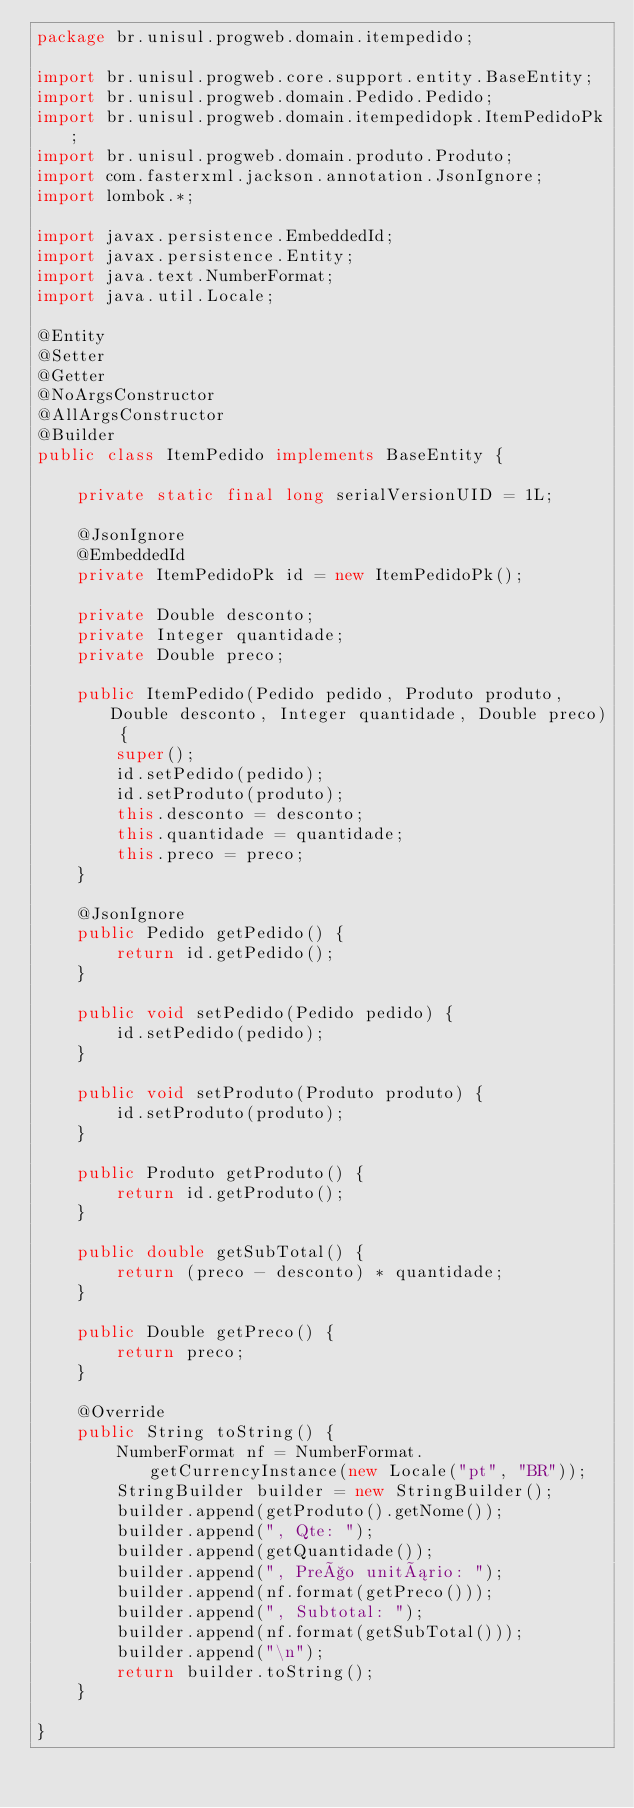Convert code to text. <code><loc_0><loc_0><loc_500><loc_500><_Java_>package br.unisul.progweb.domain.itempedido;

import br.unisul.progweb.core.support.entity.BaseEntity;
import br.unisul.progweb.domain.Pedido.Pedido;
import br.unisul.progweb.domain.itempedidopk.ItemPedidoPk;
import br.unisul.progweb.domain.produto.Produto;
import com.fasterxml.jackson.annotation.JsonIgnore;
import lombok.*;

import javax.persistence.EmbeddedId;
import javax.persistence.Entity;
import java.text.NumberFormat;
import java.util.Locale;

@Entity
@Setter
@Getter
@NoArgsConstructor
@AllArgsConstructor
@Builder
public class ItemPedido implements BaseEntity {

    private static final long serialVersionUID = 1L;

    @JsonIgnore
    @EmbeddedId
    private ItemPedidoPk id = new ItemPedidoPk();

    private Double desconto;
    private Integer quantidade;
    private Double preco;

    public ItemPedido(Pedido pedido, Produto produto, Double desconto, Integer quantidade, Double preco) {
        super();
        id.setPedido(pedido);
        id.setProduto(produto);
        this.desconto = desconto;
        this.quantidade = quantidade;
        this.preco = preco;
    }

    @JsonIgnore
    public Pedido getPedido() {
        return id.getPedido();
    }

    public void setPedido(Pedido pedido) {
        id.setPedido(pedido);
    }

    public void setProduto(Produto produto) {
        id.setProduto(produto);
    }

    public Produto getProduto() {
        return id.getProduto();
    }

    public double getSubTotal() {
        return (preco - desconto) * quantidade;
    }

    public Double getPreco() {
        return preco;
    }

    @Override
    public String toString() {
        NumberFormat nf = NumberFormat.getCurrencyInstance(new Locale("pt", "BR"));
        StringBuilder builder = new StringBuilder();
        builder.append(getProduto().getNome());
        builder.append(", Qte: ");
        builder.append(getQuantidade());
        builder.append(", Preço unitário: ");
        builder.append(nf.format(getPreco()));
        builder.append(", Subtotal: ");
        builder.append(nf.format(getSubTotal()));
        builder.append("\n");
        return builder.toString();
    }

}
</code> 